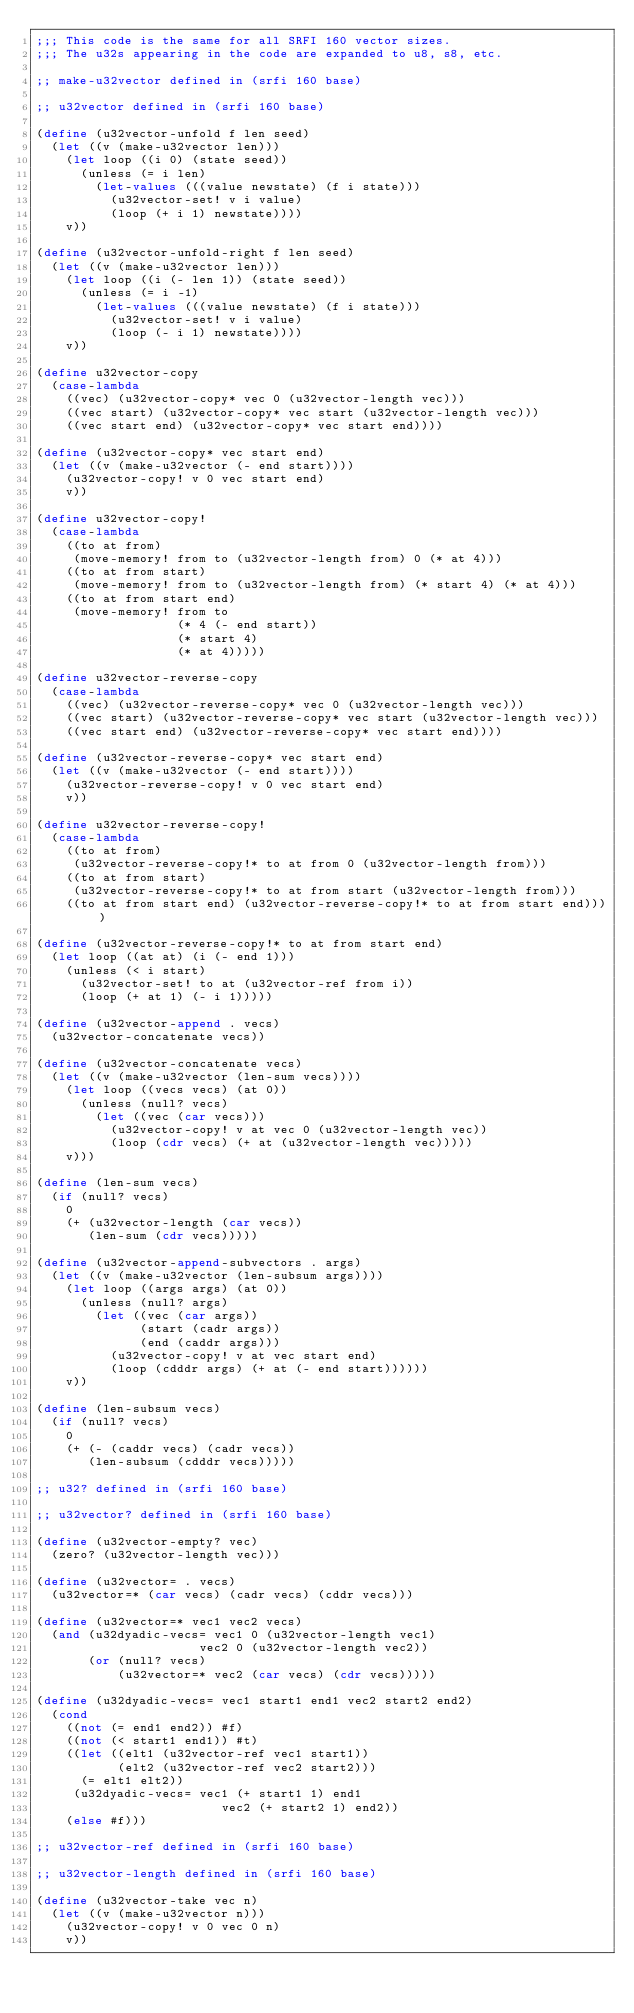<code> <loc_0><loc_0><loc_500><loc_500><_Scheme_>;;; This code is the same for all SRFI 160 vector sizes.
;;; The u32s appearing in the code are expanded to u8, s8, etc.

;; make-u32vector defined in (srfi 160 base)

;; u32vector defined in (srfi 160 base)

(define (u32vector-unfold f len seed)
  (let ((v (make-u32vector len)))
    (let loop ((i 0) (state seed))
      (unless (= i len)
        (let-values (((value newstate) (f i state)))
          (u32vector-set! v i value)
          (loop (+ i 1) newstate))))
    v))

(define (u32vector-unfold-right f len seed)
  (let ((v (make-u32vector len)))
    (let loop ((i (- len 1)) (state seed))
      (unless (= i -1)
        (let-values (((value newstate) (f i state)))
          (u32vector-set! v i value)
          (loop (- i 1) newstate))))
    v))

(define u32vector-copy
  (case-lambda
    ((vec) (u32vector-copy* vec 0 (u32vector-length vec)))
    ((vec start) (u32vector-copy* vec start (u32vector-length vec)))
    ((vec start end) (u32vector-copy* vec start end))))

(define (u32vector-copy* vec start end)
  (let ((v (make-u32vector (- end start))))
    (u32vector-copy! v 0 vec start end)
    v))

(define u32vector-copy!
  (case-lambda
    ((to at from)
     (move-memory! from to (u32vector-length from) 0 (* at 4)))
    ((to at from start)
     (move-memory! from to (u32vector-length from) (* start 4) (* at 4)))
    ((to at from start end)
     (move-memory! from to
                   (* 4 (- end start))
                   (* start 4)
                   (* at 4)))))

(define u32vector-reverse-copy
  (case-lambda
    ((vec) (u32vector-reverse-copy* vec 0 (u32vector-length vec)))
    ((vec start) (u32vector-reverse-copy* vec start (u32vector-length vec)))
    ((vec start end) (u32vector-reverse-copy* vec start end))))

(define (u32vector-reverse-copy* vec start end)
  (let ((v (make-u32vector (- end start))))
    (u32vector-reverse-copy! v 0 vec start end)
    v))

(define u32vector-reverse-copy!
  (case-lambda
    ((to at from)
     (u32vector-reverse-copy!* to at from 0 (u32vector-length from)))
    ((to at from start)
     (u32vector-reverse-copy!* to at from start (u32vector-length from)))
    ((to at from start end) (u32vector-reverse-copy!* to at from start end))))

(define (u32vector-reverse-copy!* to at from start end)
  (let loop ((at at) (i (- end 1)))
    (unless (< i start)
      (u32vector-set! to at (u32vector-ref from i))
      (loop (+ at 1) (- i 1)))))

(define (u32vector-append . vecs)
  (u32vector-concatenate vecs))

(define (u32vector-concatenate vecs)
  (let ((v (make-u32vector (len-sum vecs))))
    (let loop ((vecs vecs) (at 0))
      (unless (null? vecs)
        (let ((vec (car vecs)))
          (u32vector-copy! v at vec 0 (u32vector-length vec))
          (loop (cdr vecs) (+ at (u32vector-length vec)))))
    v)))

(define (len-sum vecs)
  (if (null? vecs)
    0
    (+ (u32vector-length (car vecs))
       (len-sum (cdr vecs)))))

(define (u32vector-append-subvectors . args)
  (let ((v (make-u32vector (len-subsum args))))
    (let loop ((args args) (at 0))
      (unless (null? args)
        (let ((vec (car args))
              (start (cadr args))
              (end (caddr args)))
          (u32vector-copy! v at vec start end)
          (loop (cdddr args) (+ at (- end start))))))
    v))

(define (len-subsum vecs)
  (if (null? vecs)
    0
    (+ (- (caddr vecs) (cadr vecs))
       (len-subsum (cdddr vecs)))))

;; u32? defined in (srfi 160 base)

;; u32vector? defined in (srfi 160 base)

(define (u32vector-empty? vec)
  (zero? (u32vector-length vec)))

(define (u32vector= . vecs)
  (u32vector=* (car vecs) (cadr vecs) (cddr vecs)))

(define (u32vector=* vec1 vec2 vecs)
  (and (u32dyadic-vecs= vec1 0 (u32vector-length vec1)
                      vec2 0 (u32vector-length vec2))
       (or (null? vecs)
           (u32vector=* vec2 (car vecs) (cdr vecs)))))

(define (u32dyadic-vecs= vec1 start1 end1 vec2 start2 end2)
  (cond
    ((not (= end1 end2)) #f)
    ((not (< start1 end1)) #t)
    ((let ((elt1 (u32vector-ref vec1 start1))
           (elt2 (u32vector-ref vec2 start2)))
      (= elt1 elt2))
     (u32dyadic-vecs= vec1 (+ start1 1) end1
                         vec2 (+ start2 1) end2))
    (else #f)))

;; u32vector-ref defined in (srfi 160 base)

;; u32vector-length defined in (srfi 160 base)

(define (u32vector-take vec n)
  (let ((v (make-u32vector n)))
    (u32vector-copy! v 0 vec 0 n)
    v))
</code> 